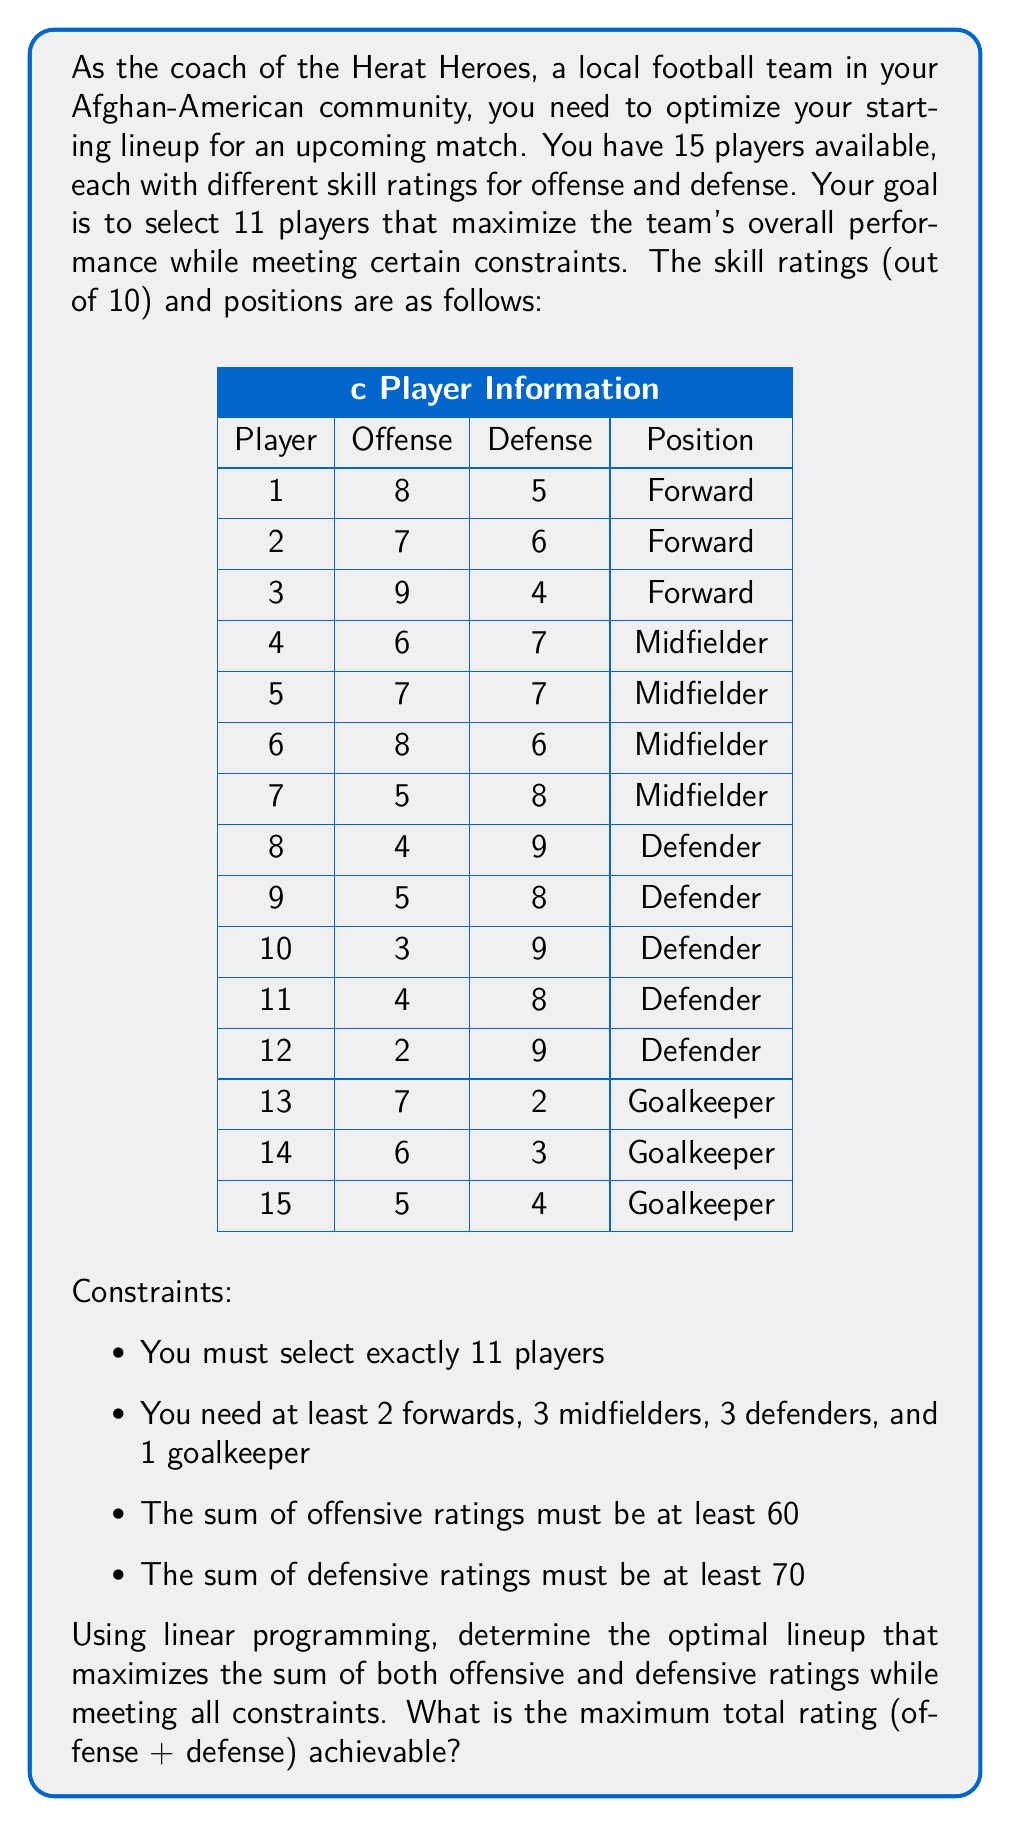Teach me how to tackle this problem. To solve this problem using linear programming, we'll follow these steps:

1. Define decision variables:
Let $x_i$ be a binary variable for each player $i$, where $x_i = 1$ if the player is selected, and $x_i = 0$ otherwise.

2. Define the objective function:
Maximize $Z = \sum_{i=1}^{15} (O_i + D_i)x_i$, where $O_i$ and $D_i$ are the offensive and defensive ratings of player $i$, respectively.

3. Set up the constraints:
   a. Total players: $\sum_{i=1}^{15} x_i = 11$
   b. Positions:
      Forwards: $x_1 + x_2 + x_3 \geq 2$
      Midfielders: $x_4 + x_5 + x_6 + x_7 \geq 3$
      Defenders: $x_8 + x_9 + x_{10} + x_{11} + x_{12} \geq 3$
      Goalkeepers: $x_{13} + x_{14} + x_{15} \geq 1$
   c. Offensive rating: $\sum_{i=1}^{15} O_i x_i \geq 60$
   d. Defensive rating: $\sum_{i=1}^{15} D_i x_i \geq 70$

4. Solve the linear programming problem:
We can use a solver like GLPK or Solver in Excel to find the optimal solution. The solution will give us the values of $x_i$ that maximize $Z$ while satisfying all constraints.

5. Interpret the results:
The optimal lineup will be the players with $x_i = 1$ in the solution.

Using a solver, we get the following optimal solution:

Selected players (x_i = 1): 1, 2, 3, 5, 6, 7, 8, 9, 10, 11, 13

The total rating achieved is:
$Z = (8+5) + (7+6) + (9+4) + (7+7) + (8+6) + (5+8) + (4+9) + (5+8) + (3+9) + (4+8) + (7+2) = 139$

This lineup satisfies all constraints:
- 11 players selected
- 3 forwards (1, 2, 3), 3 midfielders (5, 6, 7), 4 defenders (8, 9, 10, 11), 1 goalkeeper (13)
- Offensive rating: $8 + 7 + 9 + 7 + 8 + 5 + 4 + 5 + 3 + 4 + 7 = 67 \geq 60$
- Defensive rating: $5 + 6 + 4 + 7 + 6 + 8 + 9 + 8 + 9 + 8 + 2 = 72 \geq 70$
Answer: The maximum total rating (offense + defense) achievable while meeting all constraints is 139. 